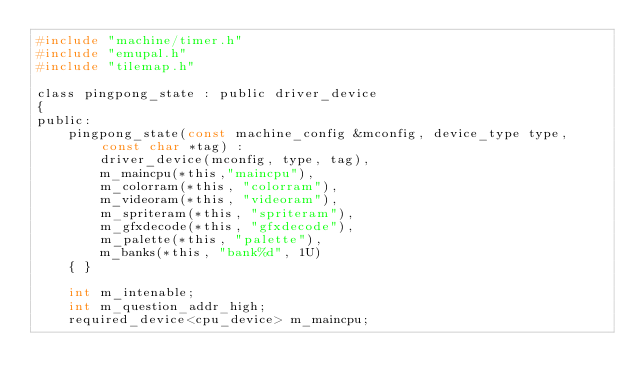<code> <loc_0><loc_0><loc_500><loc_500><_C_>#include "machine/timer.h"
#include "emupal.h"
#include "tilemap.h"

class pingpong_state : public driver_device
{
public:
	pingpong_state(const machine_config &mconfig, device_type type, const char *tag) :
		driver_device(mconfig, type, tag),
		m_maincpu(*this,"maincpu"),
		m_colorram(*this, "colorram"),
		m_videoram(*this, "videoram"),
		m_spriteram(*this, "spriteram"),
		m_gfxdecode(*this, "gfxdecode"),
		m_palette(*this, "palette"),
		m_banks(*this, "bank%d", 1U)
	{ }

	int m_intenable;
	int m_question_addr_high;
	required_device<cpu_device> m_maincpu;</code> 